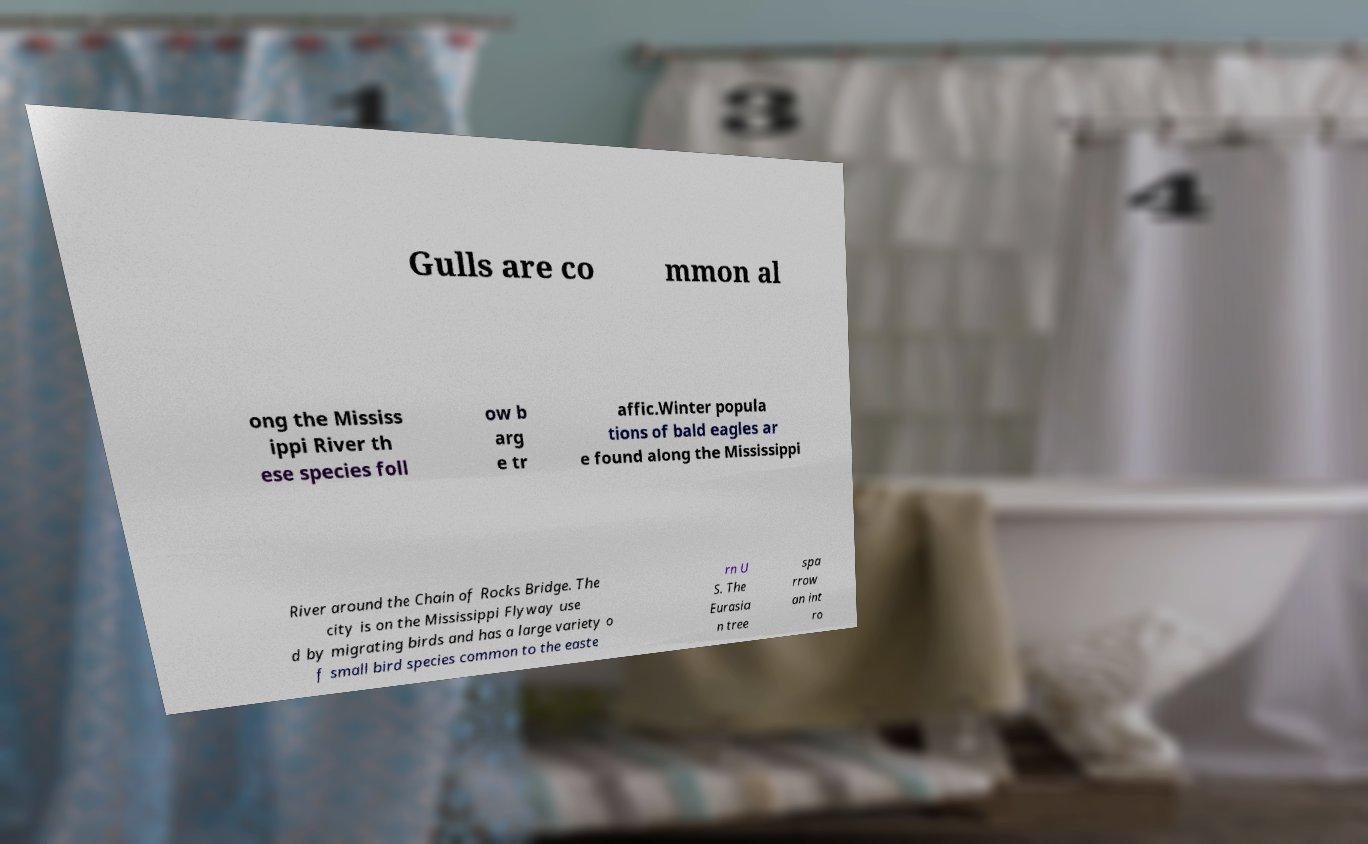What messages or text are displayed in this image? I need them in a readable, typed format. Gulls are co mmon al ong the Mississ ippi River th ese species foll ow b arg e tr affic.Winter popula tions of bald eagles ar e found along the Mississippi River around the Chain of Rocks Bridge. The city is on the Mississippi Flyway use d by migrating birds and has a large variety o f small bird species common to the easte rn U S. The Eurasia n tree spa rrow an int ro 